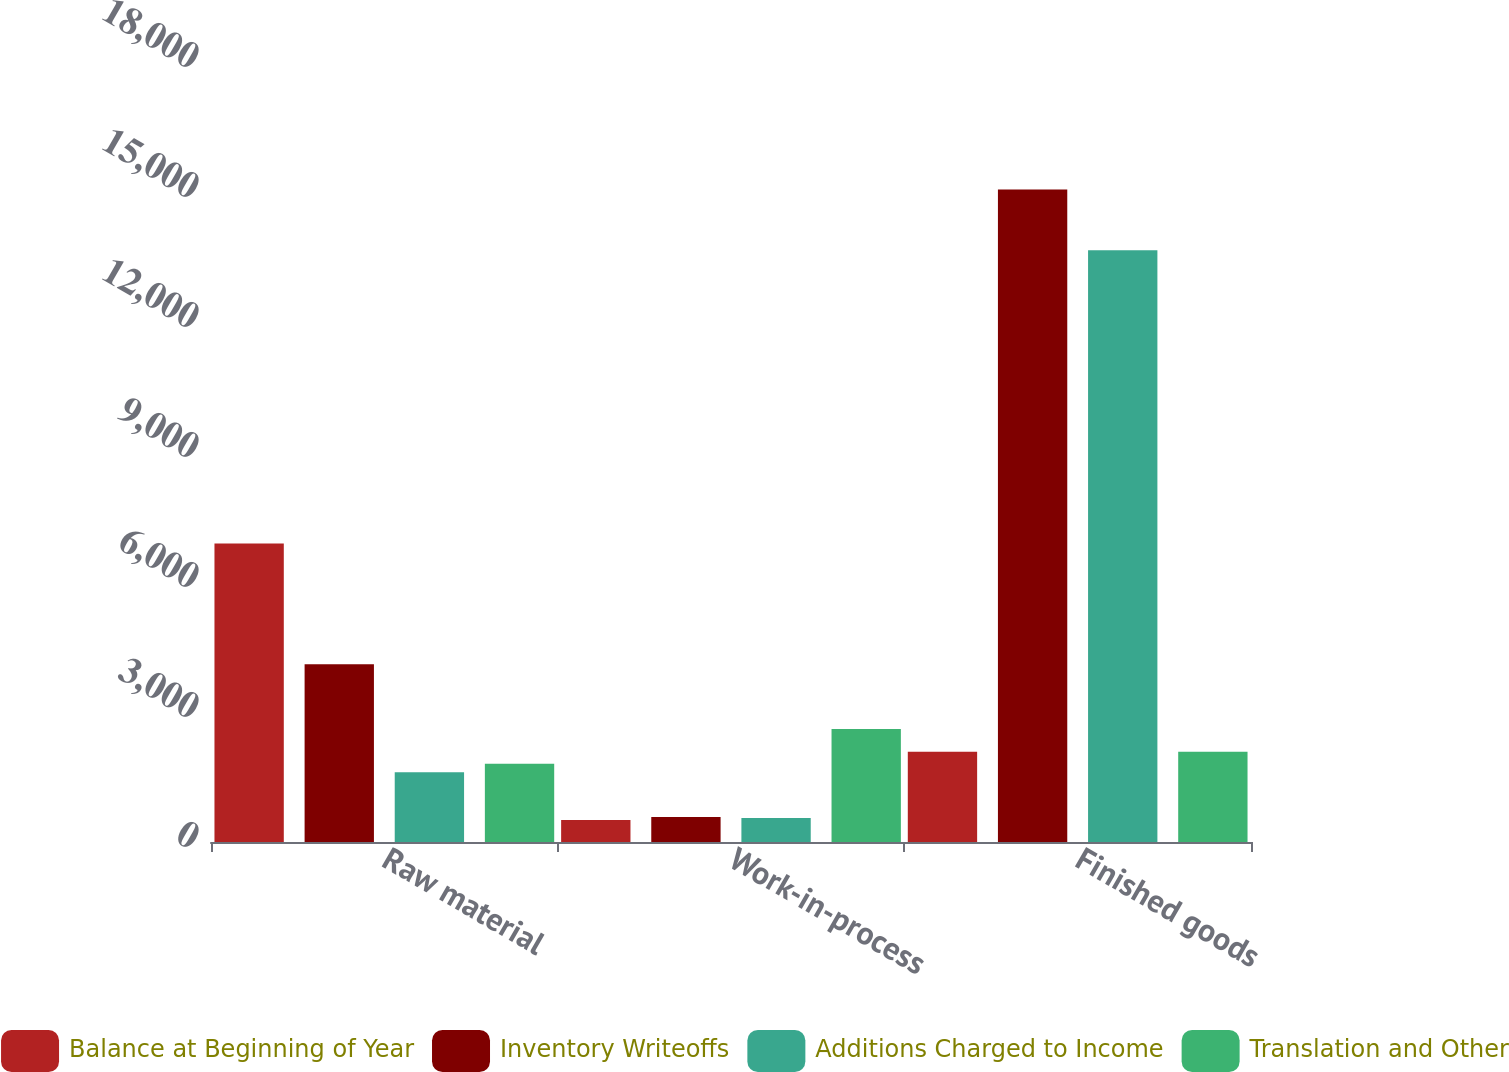Convert chart. <chart><loc_0><loc_0><loc_500><loc_500><stacked_bar_chart><ecel><fcel>Raw material<fcel>Work-in-process<fcel>Finished goods<nl><fcel>Balance at Beginning of Year<fcel>6891<fcel>509<fcel>2081<nl><fcel>Inventory Writeoffs<fcel>4102<fcel>579<fcel>15060<nl><fcel>Additions Charged to Income<fcel>1611<fcel>554<fcel>13653<nl><fcel>Translation and Other<fcel>1805<fcel>2605<fcel>2081<nl></chart> 